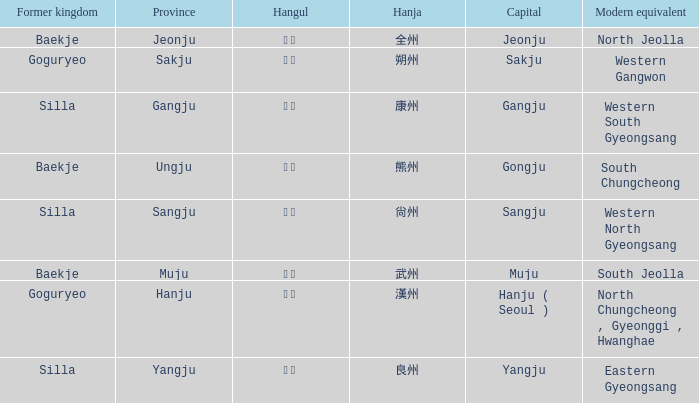What is the hanja for the province of "sangju"? 尙州. 